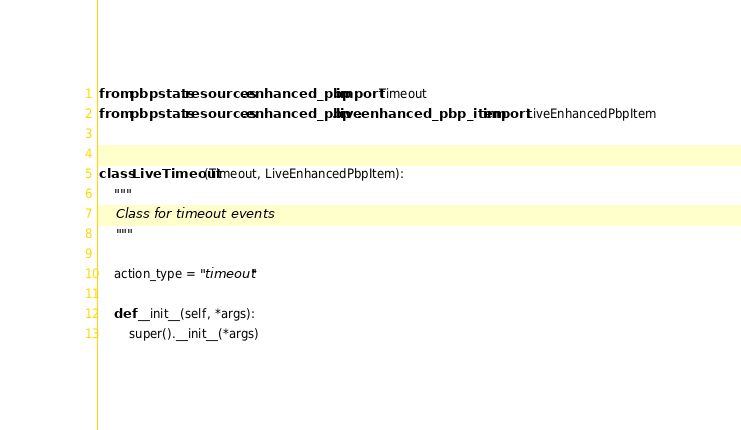Convert code to text. <code><loc_0><loc_0><loc_500><loc_500><_Python_>from pbpstats.resources.enhanced_pbp import Timeout
from pbpstats.resources.enhanced_pbp.live.enhanced_pbp_item import LiveEnhancedPbpItem


class LiveTimeout(Timeout, LiveEnhancedPbpItem):
    """
    Class for timeout events
    """

    action_type = "timeout"

    def __init__(self, *args):
        super().__init__(*args)
</code> 